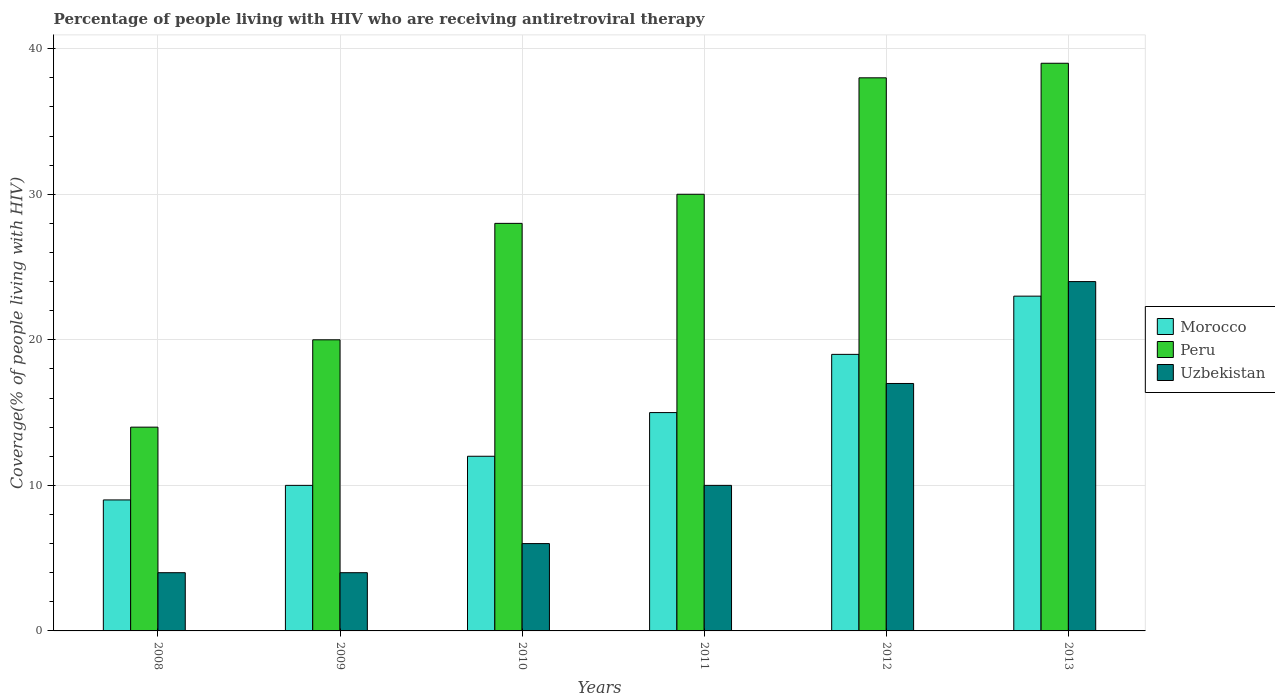How many groups of bars are there?
Your answer should be very brief. 6. Are the number of bars per tick equal to the number of legend labels?
Offer a terse response. Yes. Are the number of bars on each tick of the X-axis equal?
Provide a succinct answer. Yes. How many bars are there on the 3rd tick from the left?
Your response must be concise. 3. In how many cases, is the number of bars for a given year not equal to the number of legend labels?
Provide a succinct answer. 0. What is the percentage of the HIV infected people who are receiving antiretroviral therapy in Uzbekistan in 2008?
Your response must be concise. 4. Across all years, what is the maximum percentage of the HIV infected people who are receiving antiretroviral therapy in Peru?
Ensure brevity in your answer.  39. Across all years, what is the minimum percentage of the HIV infected people who are receiving antiretroviral therapy in Morocco?
Your answer should be very brief. 9. In which year was the percentage of the HIV infected people who are receiving antiretroviral therapy in Morocco minimum?
Provide a short and direct response. 2008. What is the total percentage of the HIV infected people who are receiving antiretroviral therapy in Uzbekistan in the graph?
Ensure brevity in your answer.  65. What is the difference between the percentage of the HIV infected people who are receiving antiretroviral therapy in Peru in 2009 and that in 2012?
Your answer should be compact. -18. What is the difference between the percentage of the HIV infected people who are receiving antiretroviral therapy in Peru in 2010 and the percentage of the HIV infected people who are receiving antiretroviral therapy in Morocco in 2013?
Keep it short and to the point. 5. What is the average percentage of the HIV infected people who are receiving antiretroviral therapy in Uzbekistan per year?
Give a very brief answer. 10.83. In the year 2008, what is the difference between the percentage of the HIV infected people who are receiving antiretroviral therapy in Uzbekistan and percentage of the HIV infected people who are receiving antiretroviral therapy in Peru?
Offer a terse response. -10. What is the ratio of the percentage of the HIV infected people who are receiving antiretroviral therapy in Morocco in 2008 to that in 2010?
Your answer should be very brief. 0.75. Is the percentage of the HIV infected people who are receiving antiretroviral therapy in Peru in 2008 less than that in 2011?
Provide a short and direct response. Yes. What is the difference between the highest and the second highest percentage of the HIV infected people who are receiving antiretroviral therapy in Morocco?
Keep it short and to the point. 4. What is the difference between the highest and the lowest percentage of the HIV infected people who are receiving antiretroviral therapy in Morocco?
Make the answer very short. 14. In how many years, is the percentage of the HIV infected people who are receiving antiretroviral therapy in Uzbekistan greater than the average percentage of the HIV infected people who are receiving antiretroviral therapy in Uzbekistan taken over all years?
Your response must be concise. 2. Is the sum of the percentage of the HIV infected people who are receiving antiretroviral therapy in Morocco in 2012 and 2013 greater than the maximum percentage of the HIV infected people who are receiving antiretroviral therapy in Peru across all years?
Keep it short and to the point. Yes. What does the 2nd bar from the right in 2012 represents?
Your response must be concise. Peru. Is it the case that in every year, the sum of the percentage of the HIV infected people who are receiving antiretroviral therapy in Peru and percentage of the HIV infected people who are receiving antiretroviral therapy in Uzbekistan is greater than the percentage of the HIV infected people who are receiving antiretroviral therapy in Morocco?
Give a very brief answer. Yes. How many years are there in the graph?
Your response must be concise. 6. How many legend labels are there?
Your response must be concise. 3. How are the legend labels stacked?
Your response must be concise. Vertical. What is the title of the graph?
Keep it short and to the point. Percentage of people living with HIV who are receiving antiretroviral therapy. What is the label or title of the X-axis?
Offer a very short reply. Years. What is the label or title of the Y-axis?
Your answer should be compact. Coverage(% of people living with HIV). What is the Coverage(% of people living with HIV) in Morocco in 2008?
Ensure brevity in your answer.  9. What is the Coverage(% of people living with HIV) in Uzbekistan in 2008?
Your response must be concise. 4. What is the Coverage(% of people living with HIV) of Morocco in 2009?
Provide a succinct answer. 10. What is the Coverage(% of people living with HIV) in Peru in 2009?
Offer a very short reply. 20. What is the Coverage(% of people living with HIV) in Uzbekistan in 2009?
Keep it short and to the point. 4. What is the Coverage(% of people living with HIV) of Morocco in 2010?
Ensure brevity in your answer.  12. What is the Coverage(% of people living with HIV) of Uzbekistan in 2010?
Your response must be concise. 6. What is the Coverage(% of people living with HIV) of Morocco in 2011?
Ensure brevity in your answer.  15. What is the Coverage(% of people living with HIV) in Peru in 2011?
Offer a terse response. 30. What is the Coverage(% of people living with HIV) in Peru in 2012?
Your answer should be very brief. 38. What is the Coverage(% of people living with HIV) of Uzbekistan in 2012?
Offer a terse response. 17. What is the Coverage(% of people living with HIV) of Morocco in 2013?
Keep it short and to the point. 23. What is the Coverage(% of people living with HIV) in Peru in 2013?
Your answer should be very brief. 39. Across all years, what is the maximum Coverage(% of people living with HIV) of Morocco?
Provide a succinct answer. 23. What is the total Coverage(% of people living with HIV) of Peru in the graph?
Keep it short and to the point. 169. What is the total Coverage(% of people living with HIV) of Uzbekistan in the graph?
Offer a very short reply. 65. What is the difference between the Coverage(% of people living with HIV) in Morocco in 2008 and that in 2009?
Offer a terse response. -1. What is the difference between the Coverage(% of people living with HIV) of Peru in 2008 and that in 2009?
Offer a terse response. -6. What is the difference between the Coverage(% of people living with HIV) of Uzbekistan in 2008 and that in 2009?
Your response must be concise. 0. What is the difference between the Coverage(% of people living with HIV) of Peru in 2008 and that in 2010?
Make the answer very short. -14. What is the difference between the Coverage(% of people living with HIV) in Uzbekistan in 2008 and that in 2010?
Offer a terse response. -2. What is the difference between the Coverage(% of people living with HIV) in Morocco in 2008 and that in 2011?
Provide a succinct answer. -6. What is the difference between the Coverage(% of people living with HIV) of Uzbekistan in 2008 and that in 2012?
Ensure brevity in your answer.  -13. What is the difference between the Coverage(% of people living with HIV) of Morocco in 2008 and that in 2013?
Provide a short and direct response. -14. What is the difference between the Coverage(% of people living with HIV) in Peru in 2008 and that in 2013?
Offer a terse response. -25. What is the difference between the Coverage(% of people living with HIV) in Uzbekistan in 2008 and that in 2013?
Offer a terse response. -20. What is the difference between the Coverage(% of people living with HIV) of Peru in 2009 and that in 2012?
Make the answer very short. -18. What is the difference between the Coverage(% of people living with HIV) in Peru in 2009 and that in 2013?
Offer a very short reply. -19. What is the difference between the Coverage(% of people living with HIV) of Morocco in 2010 and that in 2011?
Give a very brief answer. -3. What is the difference between the Coverage(% of people living with HIV) of Uzbekistan in 2010 and that in 2011?
Keep it short and to the point. -4. What is the difference between the Coverage(% of people living with HIV) in Peru in 2010 and that in 2012?
Your answer should be compact. -10. What is the difference between the Coverage(% of people living with HIV) in Uzbekistan in 2010 and that in 2012?
Offer a terse response. -11. What is the difference between the Coverage(% of people living with HIV) of Peru in 2010 and that in 2013?
Your answer should be very brief. -11. What is the difference between the Coverage(% of people living with HIV) of Peru in 2011 and that in 2012?
Keep it short and to the point. -8. What is the difference between the Coverage(% of people living with HIV) of Morocco in 2011 and that in 2013?
Your answer should be very brief. -8. What is the difference between the Coverage(% of people living with HIV) of Uzbekistan in 2011 and that in 2013?
Offer a terse response. -14. What is the difference between the Coverage(% of people living with HIV) of Morocco in 2008 and the Coverage(% of people living with HIV) of Peru in 2009?
Your answer should be compact. -11. What is the difference between the Coverage(% of people living with HIV) of Peru in 2008 and the Coverage(% of people living with HIV) of Uzbekistan in 2009?
Keep it short and to the point. 10. What is the difference between the Coverage(% of people living with HIV) of Morocco in 2008 and the Coverage(% of people living with HIV) of Peru in 2010?
Make the answer very short. -19. What is the difference between the Coverage(% of people living with HIV) of Peru in 2008 and the Coverage(% of people living with HIV) of Uzbekistan in 2010?
Provide a succinct answer. 8. What is the difference between the Coverage(% of people living with HIV) in Morocco in 2008 and the Coverage(% of people living with HIV) in Peru in 2011?
Provide a succinct answer. -21. What is the difference between the Coverage(% of people living with HIV) in Morocco in 2008 and the Coverage(% of people living with HIV) in Uzbekistan in 2011?
Ensure brevity in your answer.  -1. What is the difference between the Coverage(% of people living with HIV) in Peru in 2008 and the Coverage(% of people living with HIV) in Uzbekistan in 2011?
Your answer should be compact. 4. What is the difference between the Coverage(% of people living with HIV) of Morocco in 2008 and the Coverage(% of people living with HIV) of Peru in 2012?
Give a very brief answer. -29. What is the difference between the Coverage(% of people living with HIV) of Morocco in 2008 and the Coverage(% of people living with HIV) of Uzbekistan in 2012?
Give a very brief answer. -8. What is the difference between the Coverage(% of people living with HIV) of Peru in 2009 and the Coverage(% of people living with HIV) of Uzbekistan in 2010?
Give a very brief answer. 14. What is the difference between the Coverage(% of people living with HIV) of Morocco in 2009 and the Coverage(% of people living with HIV) of Peru in 2011?
Your answer should be very brief. -20. What is the difference between the Coverage(% of people living with HIV) in Morocco in 2009 and the Coverage(% of people living with HIV) in Uzbekistan in 2011?
Your response must be concise. 0. What is the difference between the Coverage(% of people living with HIV) in Morocco in 2009 and the Coverage(% of people living with HIV) in Uzbekistan in 2012?
Your answer should be compact. -7. What is the difference between the Coverage(% of people living with HIV) of Morocco in 2009 and the Coverage(% of people living with HIV) of Peru in 2013?
Your response must be concise. -29. What is the difference between the Coverage(% of people living with HIV) in Peru in 2010 and the Coverage(% of people living with HIV) in Uzbekistan in 2011?
Give a very brief answer. 18. What is the difference between the Coverage(% of people living with HIV) of Morocco in 2010 and the Coverage(% of people living with HIV) of Peru in 2012?
Keep it short and to the point. -26. What is the difference between the Coverage(% of people living with HIV) in Morocco in 2010 and the Coverage(% of people living with HIV) in Uzbekistan in 2012?
Your answer should be very brief. -5. What is the difference between the Coverage(% of people living with HIV) in Peru in 2010 and the Coverage(% of people living with HIV) in Uzbekistan in 2012?
Your answer should be very brief. 11. What is the difference between the Coverage(% of people living with HIV) in Morocco in 2011 and the Coverage(% of people living with HIV) in Peru in 2012?
Your response must be concise. -23. What is the difference between the Coverage(% of people living with HIV) in Peru in 2011 and the Coverage(% of people living with HIV) in Uzbekistan in 2012?
Give a very brief answer. 13. What is the difference between the Coverage(% of people living with HIV) in Peru in 2012 and the Coverage(% of people living with HIV) in Uzbekistan in 2013?
Provide a succinct answer. 14. What is the average Coverage(% of people living with HIV) in Morocco per year?
Provide a short and direct response. 14.67. What is the average Coverage(% of people living with HIV) in Peru per year?
Give a very brief answer. 28.17. What is the average Coverage(% of people living with HIV) in Uzbekistan per year?
Provide a succinct answer. 10.83. In the year 2008, what is the difference between the Coverage(% of people living with HIV) of Morocco and Coverage(% of people living with HIV) of Peru?
Your response must be concise. -5. In the year 2009, what is the difference between the Coverage(% of people living with HIV) in Peru and Coverage(% of people living with HIV) in Uzbekistan?
Make the answer very short. 16. In the year 2010, what is the difference between the Coverage(% of people living with HIV) of Peru and Coverage(% of people living with HIV) of Uzbekistan?
Your answer should be very brief. 22. In the year 2011, what is the difference between the Coverage(% of people living with HIV) in Morocco and Coverage(% of people living with HIV) in Peru?
Offer a very short reply. -15. In the year 2011, what is the difference between the Coverage(% of people living with HIV) of Peru and Coverage(% of people living with HIV) of Uzbekistan?
Give a very brief answer. 20. In the year 2012, what is the difference between the Coverage(% of people living with HIV) in Morocco and Coverage(% of people living with HIV) in Peru?
Make the answer very short. -19. In the year 2012, what is the difference between the Coverage(% of people living with HIV) in Morocco and Coverage(% of people living with HIV) in Uzbekistan?
Offer a very short reply. 2. In the year 2012, what is the difference between the Coverage(% of people living with HIV) of Peru and Coverage(% of people living with HIV) of Uzbekistan?
Offer a very short reply. 21. In the year 2013, what is the difference between the Coverage(% of people living with HIV) of Morocco and Coverage(% of people living with HIV) of Peru?
Provide a short and direct response. -16. In the year 2013, what is the difference between the Coverage(% of people living with HIV) in Morocco and Coverage(% of people living with HIV) in Uzbekistan?
Offer a very short reply. -1. What is the ratio of the Coverage(% of people living with HIV) of Morocco in 2008 to that in 2011?
Ensure brevity in your answer.  0.6. What is the ratio of the Coverage(% of people living with HIV) of Peru in 2008 to that in 2011?
Your answer should be compact. 0.47. What is the ratio of the Coverage(% of people living with HIV) in Morocco in 2008 to that in 2012?
Offer a terse response. 0.47. What is the ratio of the Coverage(% of people living with HIV) in Peru in 2008 to that in 2012?
Your answer should be compact. 0.37. What is the ratio of the Coverage(% of people living with HIV) of Uzbekistan in 2008 to that in 2012?
Provide a short and direct response. 0.24. What is the ratio of the Coverage(% of people living with HIV) of Morocco in 2008 to that in 2013?
Ensure brevity in your answer.  0.39. What is the ratio of the Coverage(% of people living with HIV) in Peru in 2008 to that in 2013?
Offer a terse response. 0.36. What is the ratio of the Coverage(% of people living with HIV) in Morocco in 2009 to that in 2010?
Offer a very short reply. 0.83. What is the ratio of the Coverage(% of people living with HIV) of Peru in 2009 to that in 2010?
Your response must be concise. 0.71. What is the ratio of the Coverage(% of people living with HIV) of Uzbekistan in 2009 to that in 2010?
Your response must be concise. 0.67. What is the ratio of the Coverage(% of people living with HIV) in Morocco in 2009 to that in 2011?
Offer a very short reply. 0.67. What is the ratio of the Coverage(% of people living with HIV) in Peru in 2009 to that in 2011?
Offer a very short reply. 0.67. What is the ratio of the Coverage(% of people living with HIV) of Morocco in 2009 to that in 2012?
Provide a short and direct response. 0.53. What is the ratio of the Coverage(% of people living with HIV) in Peru in 2009 to that in 2012?
Your answer should be compact. 0.53. What is the ratio of the Coverage(% of people living with HIV) of Uzbekistan in 2009 to that in 2012?
Provide a succinct answer. 0.24. What is the ratio of the Coverage(% of people living with HIV) of Morocco in 2009 to that in 2013?
Your answer should be compact. 0.43. What is the ratio of the Coverage(% of people living with HIV) in Peru in 2009 to that in 2013?
Your response must be concise. 0.51. What is the ratio of the Coverage(% of people living with HIV) of Uzbekistan in 2009 to that in 2013?
Provide a succinct answer. 0.17. What is the ratio of the Coverage(% of people living with HIV) in Morocco in 2010 to that in 2011?
Give a very brief answer. 0.8. What is the ratio of the Coverage(% of people living with HIV) in Peru in 2010 to that in 2011?
Make the answer very short. 0.93. What is the ratio of the Coverage(% of people living with HIV) in Morocco in 2010 to that in 2012?
Provide a succinct answer. 0.63. What is the ratio of the Coverage(% of people living with HIV) of Peru in 2010 to that in 2012?
Keep it short and to the point. 0.74. What is the ratio of the Coverage(% of people living with HIV) of Uzbekistan in 2010 to that in 2012?
Your response must be concise. 0.35. What is the ratio of the Coverage(% of people living with HIV) in Morocco in 2010 to that in 2013?
Your response must be concise. 0.52. What is the ratio of the Coverage(% of people living with HIV) in Peru in 2010 to that in 2013?
Make the answer very short. 0.72. What is the ratio of the Coverage(% of people living with HIV) in Uzbekistan in 2010 to that in 2013?
Offer a very short reply. 0.25. What is the ratio of the Coverage(% of people living with HIV) of Morocco in 2011 to that in 2012?
Give a very brief answer. 0.79. What is the ratio of the Coverage(% of people living with HIV) in Peru in 2011 to that in 2012?
Make the answer very short. 0.79. What is the ratio of the Coverage(% of people living with HIV) in Uzbekistan in 2011 to that in 2012?
Offer a very short reply. 0.59. What is the ratio of the Coverage(% of people living with HIV) in Morocco in 2011 to that in 2013?
Give a very brief answer. 0.65. What is the ratio of the Coverage(% of people living with HIV) of Peru in 2011 to that in 2013?
Ensure brevity in your answer.  0.77. What is the ratio of the Coverage(% of people living with HIV) in Uzbekistan in 2011 to that in 2013?
Offer a terse response. 0.42. What is the ratio of the Coverage(% of people living with HIV) of Morocco in 2012 to that in 2013?
Your answer should be compact. 0.83. What is the ratio of the Coverage(% of people living with HIV) of Peru in 2012 to that in 2013?
Provide a succinct answer. 0.97. What is the ratio of the Coverage(% of people living with HIV) in Uzbekistan in 2012 to that in 2013?
Make the answer very short. 0.71. What is the difference between the highest and the lowest Coverage(% of people living with HIV) of Peru?
Offer a terse response. 25. 